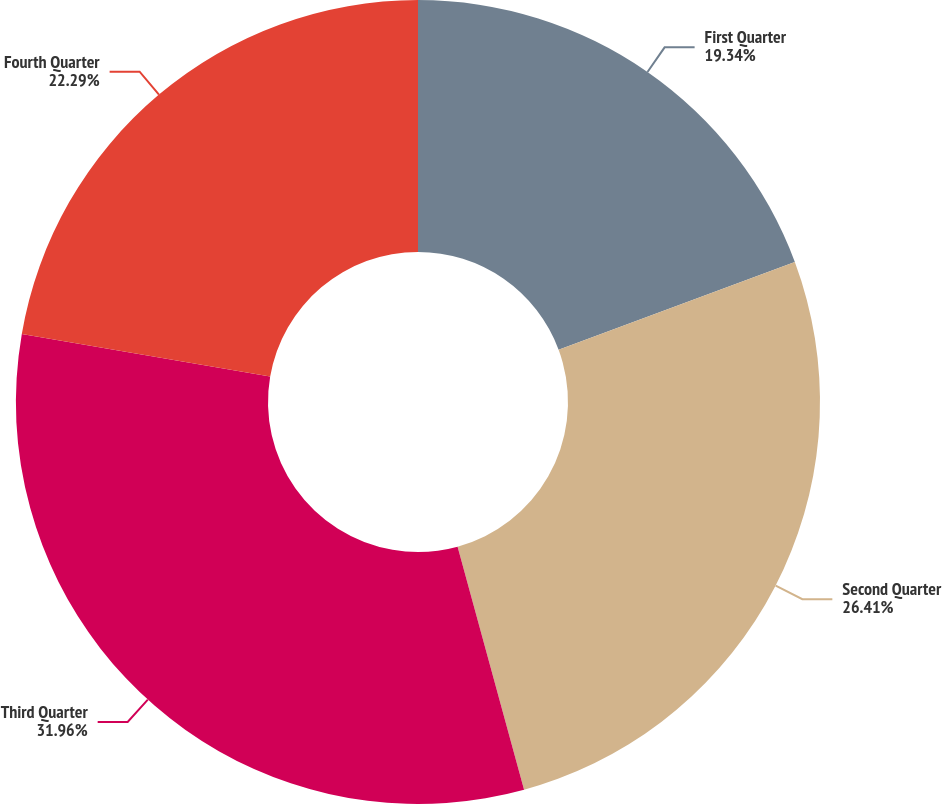Convert chart to OTSL. <chart><loc_0><loc_0><loc_500><loc_500><pie_chart><fcel>First Quarter<fcel>Second Quarter<fcel>Third Quarter<fcel>Fourth Quarter<nl><fcel>19.34%<fcel>26.41%<fcel>31.96%<fcel>22.29%<nl></chart> 